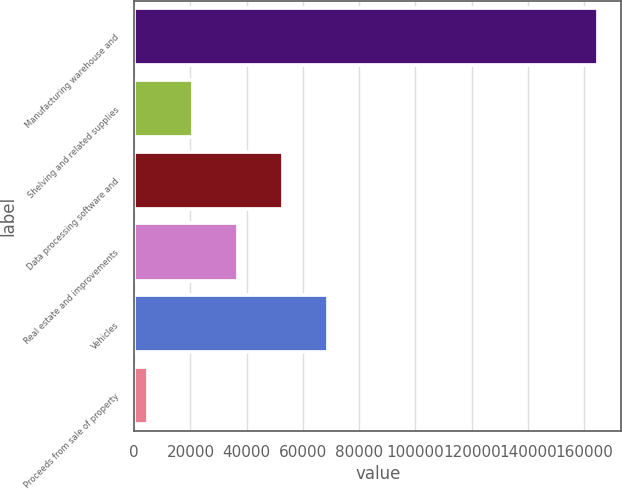<chart> <loc_0><loc_0><loc_500><loc_500><bar_chart><fcel>Manufacturing warehouse and<fcel>Shelving and related supplies<fcel>Data processing software and<fcel>Real estate and improvements<fcel>Vehicles<fcel>Proceeds from sale of property<nl><fcel>164940<fcel>20985<fcel>52975<fcel>36980<fcel>68970<fcel>4990<nl></chart> 